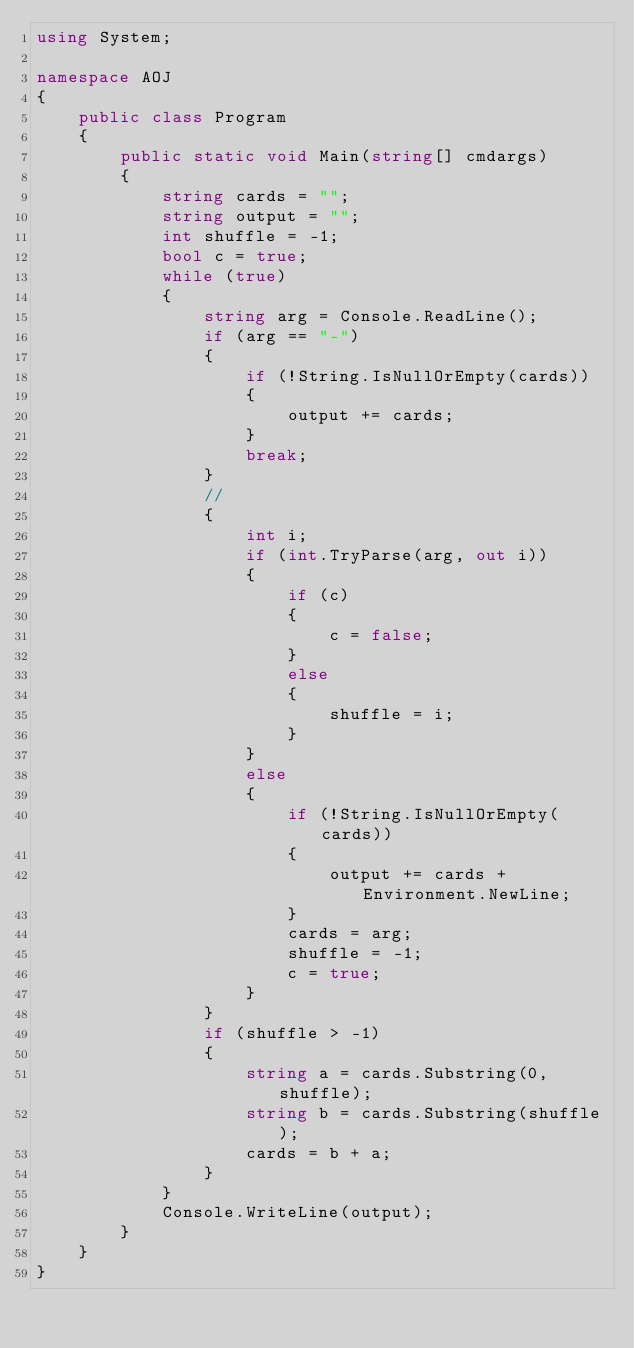Convert code to text. <code><loc_0><loc_0><loc_500><loc_500><_C#_>using System;

namespace AOJ
{
    public class Program
    {
        public static void Main(string[] cmdargs)
        {
            string cards = "";
            string output = "";
            int shuffle = -1;
            bool c = true;
            while (true)
            {
                string arg = Console.ReadLine();
                if (arg == "-")
                {
                    if (!String.IsNullOrEmpty(cards))
                    {
                        output += cards;
                    }
                    break;
                }
                //
                {
                    int i;
                    if (int.TryParse(arg, out i))
                    {
                        if (c)
                        {
                            c = false;
                        }
                        else
                        {
                            shuffle = i;
                        }
                    }
                    else
                    {
                        if (!String.IsNullOrEmpty(cards))
                        {
                            output += cards + Environment.NewLine;
                        }
                        cards = arg;
                        shuffle = -1;
                        c = true;
                    }
                }
                if (shuffle > -1)
                {
                    string a = cards.Substring(0, shuffle);
                    string b = cards.Substring(shuffle);
                    cards = b + a;
                }
            }
            Console.WriteLine(output);
        }
    }
}</code> 